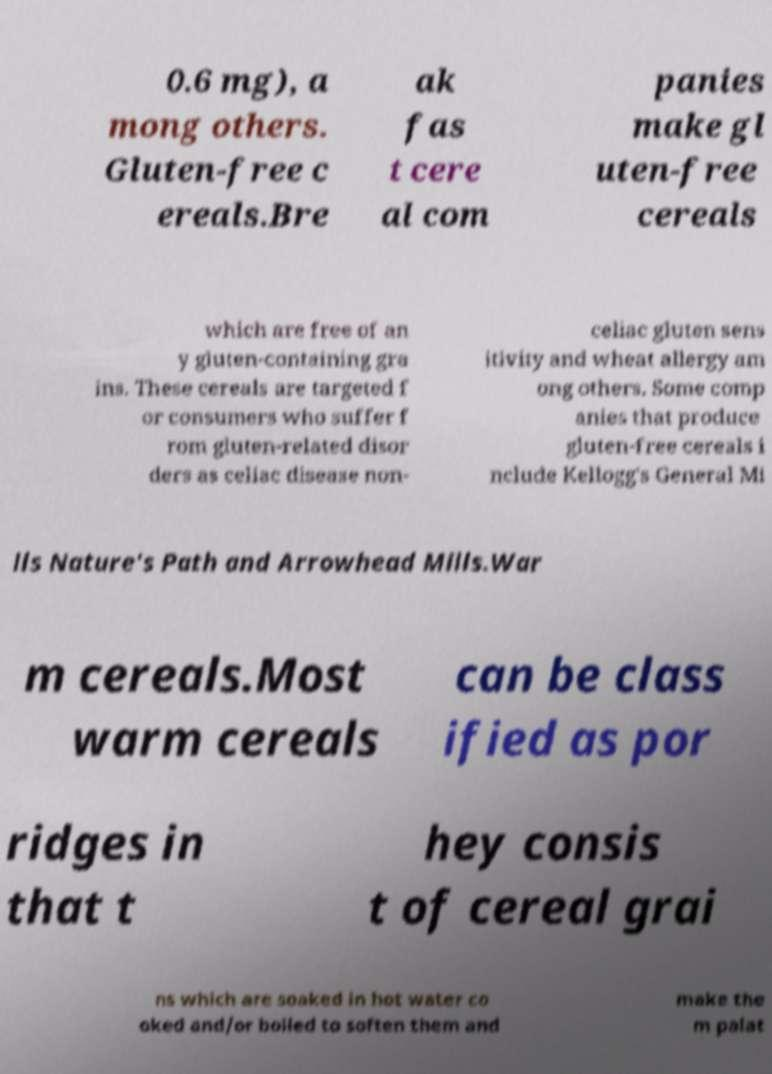Please read and relay the text visible in this image. What does it say? 0.6 mg), a mong others. Gluten-free c ereals.Bre ak fas t cere al com panies make gl uten-free cereals which are free of an y gluten-containing gra ins. These cereals are targeted f or consumers who suffer f rom gluten-related disor ders as celiac disease non- celiac gluten sens itivity and wheat allergy am ong others. Some comp anies that produce gluten-free cereals i nclude Kellogg's General Mi lls Nature's Path and Arrowhead Mills.War m cereals.Most warm cereals can be class ified as por ridges in that t hey consis t of cereal grai ns which are soaked in hot water co oked and/or boiled to soften them and make the m palat 